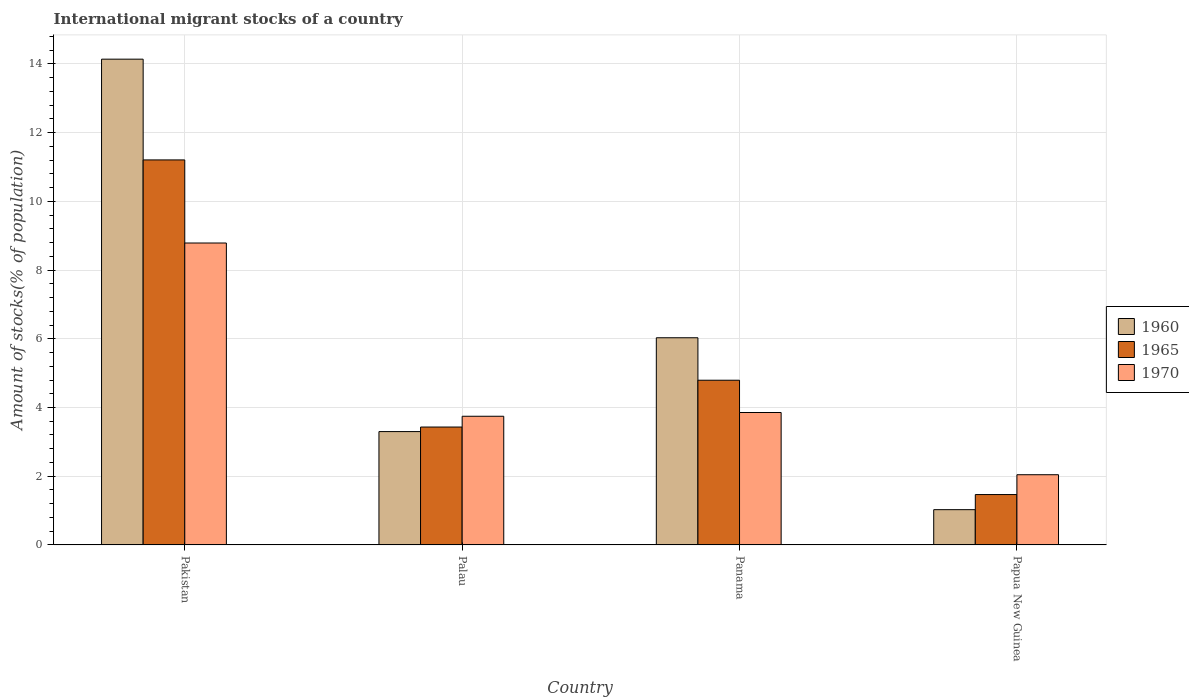How many groups of bars are there?
Keep it short and to the point. 4. Are the number of bars per tick equal to the number of legend labels?
Provide a short and direct response. Yes. How many bars are there on the 3rd tick from the left?
Keep it short and to the point. 3. What is the label of the 4th group of bars from the left?
Ensure brevity in your answer.  Papua New Guinea. What is the amount of stocks in in 1965 in Pakistan?
Give a very brief answer. 11.21. Across all countries, what is the maximum amount of stocks in in 1965?
Keep it short and to the point. 11.21. Across all countries, what is the minimum amount of stocks in in 1965?
Provide a short and direct response. 1.47. In which country was the amount of stocks in in 1970 maximum?
Give a very brief answer. Pakistan. In which country was the amount of stocks in in 1965 minimum?
Make the answer very short. Papua New Guinea. What is the total amount of stocks in in 1970 in the graph?
Provide a succinct answer. 18.43. What is the difference between the amount of stocks in in 1960 in Palau and that in Panama?
Make the answer very short. -2.73. What is the difference between the amount of stocks in in 1965 in Panama and the amount of stocks in in 1960 in Palau?
Keep it short and to the point. 1.49. What is the average amount of stocks in in 1960 per country?
Provide a succinct answer. 6.12. What is the difference between the amount of stocks in of/in 1965 and amount of stocks in of/in 1960 in Palau?
Offer a terse response. 0.13. In how many countries, is the amount of stocks in in 1965 greater than 6.4 %?
Your response must be concise. 1. What is the ratio of the amount of stocks in in 1965 in Palau to that in Papua New Guinea?
Offer a very short reply. 2.34. Is the difference between the amount of stocks in in 1965 in Palau and Papua New Guinea greater than the difference between the amount of stocks in in 1960 in Palau and Papua New Guinea?
Your response must be concise. No. What is the difference between the highest and the second highest amount of stocks in in 1970?
Your response must be concise. 4.93. What is the difference between the highest and the lowest amount of stocks in in 1970?
Provide a succinct answer. 6.74. What does the 1st bar from the right in Pakistan represents?
Provide a succinct answer. 1970. Is it the case that in every country, the sum of the amount of stocks in in 1970 and amount of stocks in in 1960 is greater than the amount of stocks in in 1965?
Make the answer very short. Yes. How many bars are there?
Your answer should be very brief. 12. What is the difference between two consecutive major ticks on the Y-axis?
Your answer should be very brief. 2. Does the graph contain grids?
Keep it short and to the point. Yes. How many legend labels are there?
Provide a succinct answer. 3. How are the legend labels stacked?
Keep it short and to the point. Vertical. What is the title of the graph?
Make the answer very short. International migrant stocks of a country. Does "1972" appear as one of the legend labels in the graph?
Provide a short and direct response. No. What is the label or title of the X-axis?
Provide a short and direct response. Country. What is the label or title of the Y-axis?
Offer a very short reply. Amount of stocks(% of population). What is the Amount of stocks(% of population) of 1960 in Pakistan?
Make the answer very short. 14.14. What is the Amount of stocks(% of population) of 1965 in Pakistan?
Keep it short and to the point. 11.21. What is the Amount of stocks(% of population) in 1970 in Pakistan?
Provide a short and direct response. 8.79. What is the Amount of stocks(% of population) in 1960 in Palau?
Your response must be concise. 3.3. What is the Amount of stocks(% of population) in 1965 in Palau?
Your answer should be very brief. 3.43. What is the Amount of stocks(% of population) of 1970 in Palau?
Your response must be concise. 3.75. What is the Amount of stocks(% of population) in 1960 in Panama?
Keep it short and to the point. 6.03. What is the Amount of stocks(% of population) of 1965 in Panama?
Your answer should be very brief. 4.79. What is the Amount of stocks(% of population) in 1970 in Panama?
Ensure brevity in your answer.  3.85. What is the Amount of stocks(% of population) in 1960 in Papua New Guinea?
Offer a terse response. 1.03. What is the Amount of stocks(% of population) in 1965 in Papua New Guinea?
Keep it short and to the point. 1.47. What is the Amount of stocks(% of population) of 1970 in Papua New Guinea?
Your answer should be very brief. 2.04. Across all countries, what is the maximum Amount of stocks(% of population) of 1960?
Offer a terse response. 14.14. Across all countries, what is the maximum Amount of stocks(% of population) in 1965?
Make the answer very short. 11.21. Across all countries, what is the maximum Amount of stocks(% of population) of 1970?
Your answer should be compact. 8.79. Across all countries, what is the minimum Amount of stocks(% of population) of 1960?
Your response must be concise. 1.03. Across all countries, what is the minimum Amount of stocks(% of population) of 1965?
Provide a succinct answer. 1.47. Across all countries, what is the minimum Amount of stocks(% of population) in 1970?
Your answer should be very brief. 2.04. What is the total Amount of stocks(% of population) in 1960 in the graph?
Your response must be concise. 24.5. What is the total Amount of stocks(% of population) in 1965 in the graph?
Your answer should be very brief. 20.9. What is the total Amount of stocks(% of population) of 1970 in the graph?
Ensure brevity in your answer.  18.43. What is the difference between the Amount of stocks(% of population) of 1960 in Pakistan and that in Palau?
Provide a succinct answer. 10.84. What is the difference between the Amount of stocks(% of population) in 1965 in Pakistan and that in Palau?
Provide a succinct answer. 7.78. What is the difference between the Amount of stocks(% of population) in 1970 in Pakistan and that in Palau?
Your answer should be compact. 5.04. What is the difference between the Amount of stocks(% of population) of 1960 in Pakistan and that in Panama?
Give a very brief answer. 8.11. What is the difference between the Amount of stocks(% of population) in 1965 in Pakistan and that in Panama?
Keep it short and to the point. 6.41. What is the difference between the Amount of stocks(% of population) of 1970 in Pakistan and that in Panama?
Offer a very short reply. 4.93. What is the difference between the Amount of stocks(% of population) in 1960 in Pakistan and that in Papua New Guinea?
Offer a very short reply. 13.11. What is the difference between the Amount of stocks(% of population) in 1965 in Pakistan and that in Papua New Guinea?
Your response must be concise. 9.74. What is the difference between the Amount of stocks(% of population) of 1970 in Pakistan and that in Papua New Guinea?
Offer a terse response. 6.74. What is the difference between the Amount of stocks(% of population) in 1960 in Palau and that in Panama?
Keep it short and to the point. -2.73. What is the difference between the Amount of stocks(% of population) in 1965 in Palau and that in Panama?
Your response must be concise. -1.36. What is the difference between the Amount of stocks(% of population) in 1970 in Palau and that in Panama?
Make the answer very short. -0.11. What is the difference between the Amount of stocks(% of population) of 1960 in Palau and that in Papua New Guinea?
Ensure brevity in your answer.  2.27. What is the difference between the Amount of stocks(% of population) of 1965 in Palau and that in Papua New Guinea?
Keep it short and to the point. 1.97. What is the difference between the Amount of stocks(% of population) of 1970 in Palau and that in Papua New Guinea?
Keep it short and to the point. 1.7. What is the difference between the Amount of stocks(% of population) in 1960 in Panama and that in Papua New Guinea?
Keep it short and to the point. 5. What is the difference between the Amount of stocks(% of population) of 1965 in Panama and that in Papua New Guinea?
Ensure brevity in your answer.  3.33. What is the difference between the Amount of stocks(% of population) in 1970 in Panama and that in Papua New Guinea?
Keep it short and to the point. 1.81. What is the difference between the Amount of stocks(% of population) of 1960 in Pakistan and the Amount of stocks(% of population) of 1965 in Palau?
Your response must be concise. 10.71. What is the difference between the Amount of stocks(% of population) of 1960 in Pakistan and the Amount of stocks(% of population) of 1970 in Palau?
Your response must be concise. 10.39. What is the difference between the Amount of stocks(% of population) in 1965 in Pakistan and the Amount of stocks(% of population) in 1970 in Palau?
Provide a succinct answer. 7.46. What is the difference between the Amount of stocks(% of population) of 1960 in Pakistan and the Amount of stocks(% of population) of 1965 in Panama?
Give a very brief answer. 9.35. What is the difference between the Amount of stocks(% of population) of 1960 in Pakistan and the Amount of stocks(% of population) of 1970 in Panama?
Your response must be concise. 10.29. What is the difference between the Amount of stocks(% of population) in 1965 in Pakistan and the Amount of stocks(% of population) in 1970 in Panama?
Provide a short and direct response. 7.35. What is the difference between the Amount of stocks(% of population) in 1960 in Pakistan and the Amount of stocks(% of population) in 1965 in Papua New Guinea?
Offer a terse response. 12.67. What is the difference between the Amount of stocks(% of population) in 1960 in Pakistan and the Amount of stocks(% of population) in 1970 in Papua New Guinea?
Offer a very short reply. 12.1. What is the difference between the Amount of stocks(% of population) of 1965 in Pakistan and the Amount of stocks(% of population) of 1970 in Papua New Guinea?
Your answer should be compact. 9.16. What is the difference between the Amount of stocks(% of population) in 1960 in Palau and the Amount of stocks(% of population) in 1965 in Panama?
Keep it short and to the point. -1.49. What is the difference between the Amount of stocks(% of population) in 1960 in Palau and the Amount of stocks(% of population) in 1970 in Panama?
Your response must be concise. -0.56. What is the difference between the Amount of stocks(% of population) in 1965 in Palau and the Amount of stocks(% of population) in 1970 in Panama?
Your answer should be compact. -0.42. What is the difference between the Amount of stocks(% of population) in 1960 in Palau and the Amount of stocks(% of population) in 1965 in Papua New Guinea?
Provide a succinct answer. 1.83. What is the difference between the Amount of stocks(% of population) of 1960 in Palau and the Amount of stocks(% of population) of 1970 in Papua New Guinea?
Keep it short and to the point. 1.26. What is the difference between the Amount of stocks(% of population) in 1965 in Palau and the Amount of stocks(% of population) in 1970 in Papua New Guinea?
Offer a terse response. 1.39. What is the difference between the Amount of stocks(% of population) in 1960 in Panama and the Amount of stocks(% of population) in 1965 in Papua New Guinea?
Make the answer very short. 4.56. What is the difference between the Amount of stocks(% of population) in 1960 in Panama and the Amount of stocks(% of population) in 1970 in Papua New Guinea?
Offer a terse response. 3.99. What is the difference between the Amount of stocks(% of population) of 1965 in Panama and the Amount of stocks(% of population) of 1970 in Papua New Guinea?
Make the answer very short. 2.75. What is the average Amount of stocks(% of population) of 1960 per country?
Ensure brevity in your answer.  6.12. What is the average Amount of stocks(% of population) in 1965 per country?
Offer a very short reply. 5.22. What is the average Amount of stocks(% of population) in 1970 per country?
Give a very brief answer. 4.61. What is the difference between the Amount of stocks(% of population) of 1960 and Amount of stocks(% of population) of 1965 in Pakistan?
Ensure brevity in your answer.  2.93. What is the difference between the Amount of stocks(% of population) in 1960 and Amount of stocks(% of population) in 1970 in Pakistan?
Provide a succinct answer. 5.35. What is the difference between the Amount of stocks(% of population) in 1965 and Amount of stocks(% of population) in 1970 in Pakistan?
Offer a very short reply. 2.42. What is the difference between the Amount of stocks(% of population) in 1960 and Amount of stocks(% of population) in 1965 in Palau?
Offer a terse response. -0.13. What is the difference between the Amount of stocks(% of population) in 1960 and Amount of stocks(% of population) in 1970 in Palau?
Your response must be concise. -0.45. What is the difference between the Amount of stocks(% of population) of 1965 and Amount of stocks(% of population) of 1970 in Palau?
Keep it short and to the point. -0.31. What is the difference between the Amount of stocks(% of population) of 1960 and Amount of stocks(% of population) of 1965 in Panama?
Your answer should be compact. 1.24. What is the difference between the Amount of stocks(% of population) of 1960 and Amount of stocks(% of population) of 1970 in Panama?
Offer a very short reply. 2.18. What is the difference between the Amount of stocks(% of population) in 1965 and Amount of stocks(% of population) in 1970 in Panama?
Ensure brevity in your answer.  0.94. What is the difference between the Amount of stocks(% of population) of 1960 and Amount of stocks(% of population) of 1965 in Papua New Guinea?
Give a very brief answer. -0.44. What is the difference between the Amount of stocks(% of population) in 1960 and Amount of stocks(% of population) in 1970 in Papua New Guinea?
Ensure brevity in your answer.  -1.02. What is the difference between the Amount of stocks(% of population) in 1965 and Amount of stocks(% of population) in 1970 in Papua New Guinea?
Ensure brevity in your answer.  -0.58. What is the ratio of the Amount of stocks(% of population) in 1960 in Pakistan to that in Palau?
Provide a succinct answer. 4.29. What is the ratio of the Amount of stocks(% of population) of 1965 in Pakistan to that in Palau?
Ensure brevity in your answer.  3.27. What is the ratio of the Amount of stocks(% of population) in 1970 in Pakistan to that in Palau?
Give a very brief answer. 2.35. What is the ratio of the Amount of stocks(% of population) in 1960 in Pakistan to that in Panama?
Your answer should be compact. 2.34. What is the ratio of the Amount of stocks(% of population) in 1965 in Pakistan to that in Panama?
Provide a succinct answer. 2.34. What is the ratio of the Amount of stocks(% of population) of 1970 in Pakistan to that in Panama?
Give a very brief answer. 2.28. What is the ratio of the Amount of stocks(% of population) of 1960 in Pakistan to that in Papua New Guinea?
Offer a very short reply. 13.78. What is the ratio of the Amount of stocks(% of population) in 1965 in Pakistan to that in Papua New Guinea?
Offer a terse response. 7.64. What is the ratio of the Amount of stocks(% of population) of 1970 in Pakistan to that in Papua New Guinea?
Ensure brevity in your answer.  4.3. What is the ratio of the Amount of stocks(% of population) of 1960 in Palau to that in Panama?
Offer a terse response. 0.55. What is the ratio of the Amount of stocks(% of population) in 1965 in Palau to that in Panama?
Offer a terse response. 0.72. What is the ratio of the Amount of stocks(% of population) of 1970 in Palau to that in Panama?
Give a very brief answer. 0.97. What is the ratio of the Amount of stocks(% of population) in 1960 in Palau to that in Papua New Guinea?
Provide a succinct answer. 3.21. What is the ratio of the Amount of stocks(% of population) in 1965 in Palau to that in Papua New Guinea?
Offer a terse response. 2.34. What is the ratio of the Amount of stocks(% of population) of 1970 in Palau to that in Papua New Guinea?
Provide a succinct answer. 1.83. What is the ratio of the Amount of stocks(% of population) in 1960 in Panama to that in Papua New Guinea?
Provide a succinct answer. 5.88. What is the ratio of the Amount of stocks(% of population) of 1965 in Panama to that in Papua New Guinea?
Your answer should be compact. 3.27. What is the ratio of the Amount of stocks(% of population) in 1970 in Panama to that in Papua New Guinea?
Make the answer very short. 1.89. What is the difference between the highest and the second highest Amount of stocks(% of population) of 1960?
Your answer should be compact. 8.11. What is the difference between the highest and the second highest Amount of stocks(% of population) in 1965?
Keep it short and to the point. 6.41. What is the difference between the highest and the second highest Amount of stocks(% of population) of 1970?
Ensure brevity in your answer.  4.93. What is the difference between the highest and the lowest Amount of stocks(% of population) of 1960?
Keep it short and to the point. 13.11. What is the difference between the highest and the lowest Amount of stocks(% of population) in 1965?
Offer a very short reply. 9.74. What is the difference between the highest and the lowest Amount of stocks(% of population) of 1970?
Make the answer very short. 6.74. 